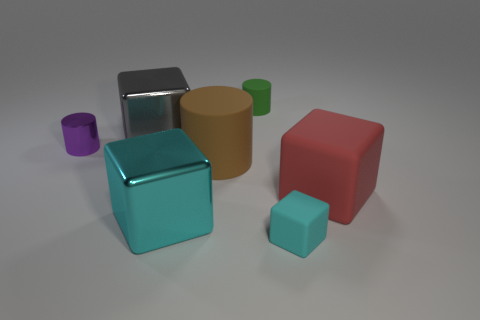Is there another block of the same color as the tiny rubber block?
Give a very brief answer. Yes. There is a cyan block on the left side of the green object; is there a rubber block in front of it?
Make the answer very short. Yes. Is there a big brown cylinder made of the same material as the purple cylinder?
Provide a short and direct response. No. What material is the small cylinder in front of the cylinder that is behind the gray metal thing?
Your response must be concise. Metal. The thing that is right of the brown rubber cylinder and behind the tiny metallic cylinder is made of what material?
Offer a terse response. Rubber. Are there the same number of objects on the left side of the red cube and big objects?
Keep it short and to the point. No. How many tiny green metal objects have the same shape as the small cyan matte object?
Your answer should be compact. 0. There is a block on the left side of the metal thing in front of the rubber block behind the small rubber block; what size is it?
Offer a terse response. Large. Is the large cube behind the large red thing made of the same material as the brown cylinder?
Provide a short and direct response. No. Is the number of big cyan metal cubes left of the small purple cylinder the same as the number of big blocks that are to the left of the big brown matte cylinder?
Provide a succinct answer. No. 